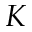Convert formula to latex. <formula><loc_0><loc_0><loc_500><loc_500>K</formula> 